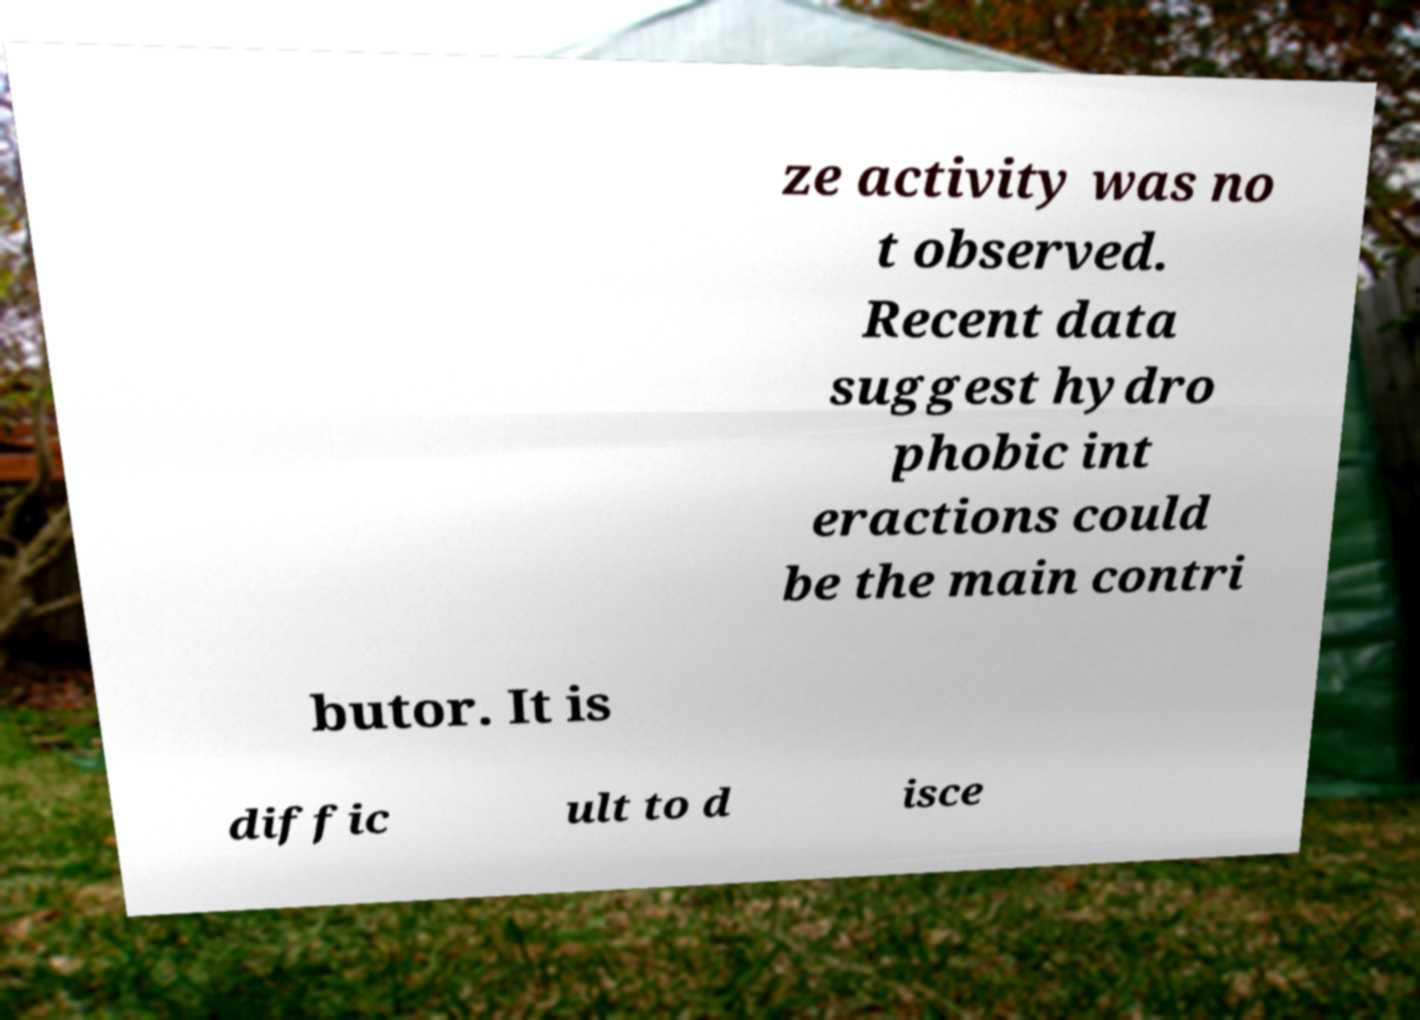Please read and relay the text visible in this image. What does it say? ze activity was no t observed. Recent data suggest hydro phobic int eractions could be the main contri butor. It is diffic ult to d isce 